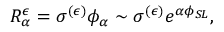<formula> <loc_0><loc_0><loc_500><loc_500>R _ { \alpha } ^ { \epsilon } = \sigma ^ { ( \epsilon ) } \phi _ { \alpha } \sim \sigma ^ { ( \epsilon ) } e ^ { \alpha \phi _ { S L } } ,</formula> 